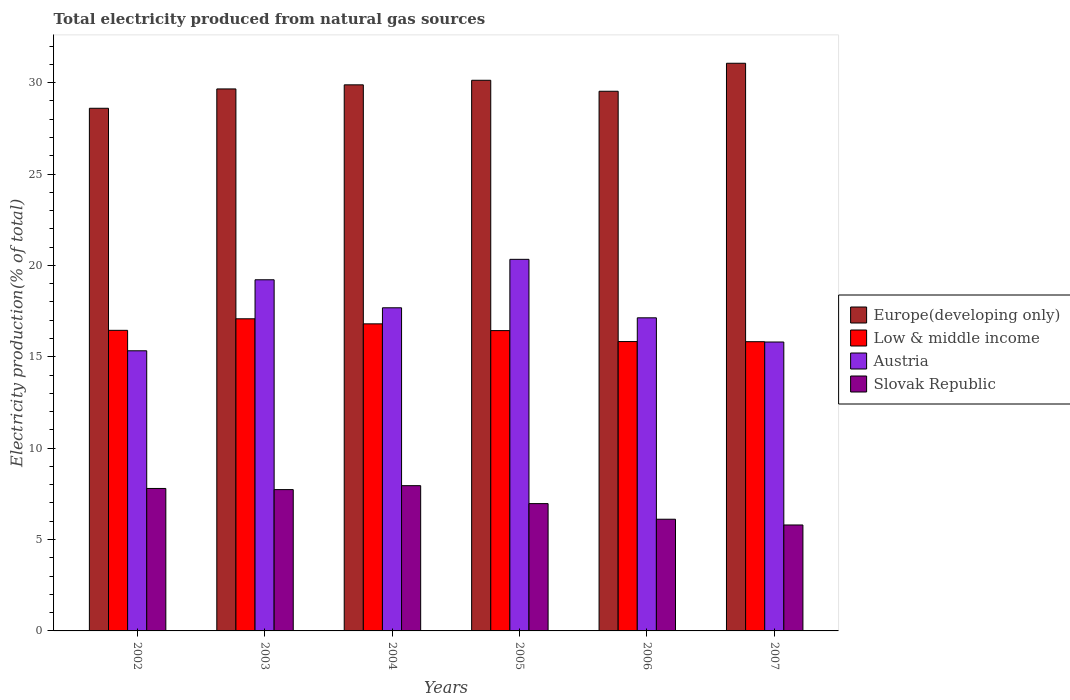How many groups of bars are there?
Keep it short and to the point. 6. Are the number of bars on each tick of the X-axis equal?
Your answer should be very brief. Yes. How many bars are there on the 4th tick from the right?
Make the answer very short. 4. What is the label of the 2nd group of bars from the left?
Make the answer very short. 2003. What is the total electricity produced in Austria in 2004?
Provide a succinct answer. 17.68. Across all years, what is the maximum total electricity produced in Slovak Republic?
Provide a short and direct response. 7.95. Across all years, what is the minimum total electricity produced in Low & middle income?
Offer a terse response. 15.83. In which year was the total electricity produced in Slovak Republic maximum?
Offer a terse response. 2004. What is the total total electricity produced in Low & middle income in the graph?
Provide a short and direct response. 98.42. What is the difference between the total electricity produced in Europe(developing only) in 2003 and that in 2005?
Make the answer very short. -0.47. What is the difference between the total electricity produced in Low & middle income in 2005 and the total electricity produced in Slovak Republic in 2004?
Give a very brief answer. 8.48. What is the average total electricity produced in Europe(developing only) per year?
Make the answer very short. 29.81. In the year 2003, what is the difference between the total electricity produced in Austria and total electricity produced in Europe(developing only)?
Give a very brief answer. -10.44. In how many years, is the total electricity produced in Slovak Republic greater than 1 %?
Your answer should be compact. 6. What is the ratio of the total electricity produced in Austria in 2003 to that in 2007?
Your answer should be compact. 1.22. Is the total electricity produced in Low & middle income in 2002 less than that in 2005?
Your answer should be very brief. No. Is the difference between the total electricity produced in Austria in 2005 and 2006 greater than the difference between the total electricity produced in Europe(developing only) in 2005 and 2006?
Provide a succinct answer. Yes. What is the difference between the highest and the second highest total electricity produced in Europe(developing only)?
Offer a terse response. 0.93. What is the difference between the highest and the lowest total electricity produced in Slovak Republic?
Provide a short and direct response. 2.15. What does the 4th bar from the right in 2007 represents?
Give a very brief answer. Europe(developing only). How many bars are there?
Make the answer very short. 24. Are all the bars in the graph horizontal?
Your response must be concise. No. How many years are there in the graph?
Provide a short and direct response. 6. What is the difference between two consecutive major ticks on the Y-axis?
Ensure brevity in your answer.  5. Are the values on the major ticks of Y-axis written in scientific E-notation?
Your answer should be very brief. No. Does the graph contain any zero values?
Provide a succinct answer. No. Does the graph contain grids?
Provide a short and direct response. No. How many legend labels are there?
Keep it short and to the point. 4. How are the legend labels stacked?
Provide a succinct answer. Vertical. What is the title of the graph?
Your answer should be compact. Total electricity produced from natural gas sources. What is the label or title of the X-axis?
Provide a succinct answer. Years. What is the label or title of the Y-axis?
Ensure brevity in your answer.  Electricity production(% of total). What is the Electricity production(% of total) in Europe(developing only) in 2002?
Provide a short and direct response. 28.6. What is the Electricity production(% of total) of Low & middle income in 2002?
Your answer should be very brief. 16.45. What is the Electricity production(% of total) of Austria in 2002?
Keep it short and to the point. 15.33. What is the Electricity production(% of total) of Slovak Republic in 2002?
Offer a terse response. 7.8. What is the Electricity production(% of total) of Europe(developing only) in 2003?
Keep it short and to the point. 29.66. What is the Electricity production(% of total) in Low & middle income in 2003?
Your answer should be compact. 17.08. What is the Electricity production(% of total) of Austria in 2003?
Offer a terse response. 19.21. What is the Electricity production(% of total) in Slovak Republic in 2003?
Give a very brief answer. 7.73. What is the Electricity production(% of total) in Europe(developing only) in 2004?
Offer a very short reply. 29.88. What is the Electricity production(% of total) in Low & middle income in 2004?
Provide a short and direct response. 16.8. What is the Electricity production(% of total) of Austria in 2004?
Your response must be concise. 17.68. What is the Electricity production(% of total) of Slovak Republic in 2004?
Give a very brief answer. 7.95. What is the Electricity production(% of total) of Europe(developing only) in 2005?
Provide a short and direct response. 30.13. What is the Electricity production(% of total) in Low & middle income in 2005?
Provide a succinct answer. 16.43. What is the Electricity production(% of total) of Austria in 2005?
Offer a very short reply. 20.33. What is the Electricity production(% of total) of Slovak Republic in 2005?
Ensure brevity in your answer.  6.97. What is the Electricity production(% of total) of Europe(developing only) in 2006?
Your answer should be very brief. 29.53. What is the Electricity production(% of total) of Low & middle income in 2006?
Ensure brevity in your answer.  15.83. What is the Electricity production(% of total) of Austria in 2006?
Provide a succinct answer. 17.13. What is the Electricity production(% of total) in Slovak Republic in 2006?
Keep it short and to the point. 6.11. What is the Electricity production(% of total) of Europe(developing only) in 2007?
Give a very brief answer. 31.06. What is the Electricity production(% of total) of Low & middle income in 2007?
Offer a terse response. 15.83. What is the Electricity production(% of total) of Austria in 2007?
Offer a very short reply. 15.81. What is the Electricity production(% of total) of Slovak Republic in 2007?
Your answer should be compact. 5.8. Across all years, what is the maximum Electricity production(% of total) in Europe(developing only)?
Your response must be concise. 31.06. Across all years, what is the maximum Electricity production(% of total) of Low & middle income?
Your answer should be very brief. 17.08. Across all years, what is the maximum Electricity production(% of total) of Austria?
Your answer should be very brief. 20.33. Across all years, what is the maximum Electricity production(% of total) of Slovak Republic?
Provide a short and direct response. 7.95. Across all years, what is the minimum Electricity production(% of total) of Europe(developing only)?
Your answer should be very brief. 28.6. Across all years, what is the minimum Electricity production(% of total) of Low & middle income?
Make the answer very short. 15.83. Across all years, what is the minimum Electricity production(% of total) of Austria?
Offer a terse response. 15.33. Across all years, what is the minimum Electricity production(% of total) in Slovak Republic?
Your answer should be very brief. 5.8. What is the total Electricity production(% of total) in Europe(developing only) in the graph?
Your answer should be very brief. 178.86. What is the total Electricity production(% of total) of Low & middle income in the graph?
Offer a terse response. 98.42. What is the total Electricity production(% of total) in Austria in the graph?
Your answer should be very brief. 105.5. What is the total Electricity production(% of total) in Slovak Republic in the graph?
Your response must be concise. 42.35. What is the difference between the Electricity production(% of total) in Europe(developing only) in 2002 and that in 2003?
Provide a succinct answer. -1.06. What is the difference between the Electricity production(% of total) in Low & middle income in 2002 and that in 2003?
Make the answer very short. -0.63. What is the difference between the Electricity production(% of total) of Austria in 2002 and that in 2003?
Offer a terse response. -3.89. What is the difference between the Electricity production(% of total) of Slovak Republic in 2002 and that in 2003?
Offer a very short reply. 0.06. What is the difference between the Electricity production(% of total) in Europe(developing only) in 2002 and that in 2004?
Provide a short and direct response. -1.28. What is the difference between the Electricity production(% of total) in Low & middle income in 2002 and that in 2004?
Ensure brevity in your answer.  -0.35. What is the difference between the Electricity production(% of total) of Austria in 2002 and that in 2004?
Your answer should be very brief. -2.35. What is the difference between the Electricity production(% of total) in Slovak Republic in 2002 and that in 2004?
Provide a short and direct response. -0.15. What is the difference between the Electricity production(% of total) in Europe(developing only) in 2002 and that in 2005?
Provide a short and direct response. -1.53. What is the difference between the Electricity production(% of total) of Low & middle income in 2002 and that in 2005?
Offer a very short reply. 0.01. What is the difference between the Electricity production(% of total) of Austria in 2002 and that in 2005?
Give a very brief answer. -5. What is the difference between the Electricity production(% of total) in Slovak Republic in 2002 and that in 2005?
Offer a very short reply. 0.83. What is the difference between the Electricity production(% of total) in Europe(developing only) in 2002 and that in 2006?
Keep it short and to the point. -0.93. What is the difference between the Electricity production(% of total) of Low & middle income in 2002 and that in 2006?
Ensure brevity in your answer.  0.61. What is the difference between the Electricity production(% of total) in Austria in 2002 and that in 2006?
Offer a very short reply. -1.8. What is the difference between the Electricity production(% of total) in Slovak Republic in 2002 and that in 2006?
Make the answer very short. 1.68. What is the difference between the Electricity production(% of total) of Europe(developing only) in 2002 and that in 2007?
Ensure brevity in your answer.  -2.46. What is the difference between the Electricity production(% of total) in Low & middle income in 2002 and that in 2007?
Give a very brief answer. 0.62. What is the difference between the Electricity production(% of total) in Austria in 2002 and that in 2007?
Ensure brevity in your answer.  -0.48. What is the difference between the Electricity production(% of total) in Slovak Republic in 2002 and that in 2007?
Offer a terse response. 2. What is the difference between the Electricity production(% of total) of Europe(developing only) in 2003 and that in 2004?
Provide a succinct answer. -0.22. What is the difference between the Electricity production(% of total) of Low & middle income in 2003 and that in 2004?
Your answer should be compact. 0.28. What is the difference between the Electricity production(% of total) of Austria in 2003 and that in 2004?
Make the answer very short. 1.53. What is the difference between the Electricity production(% of total) in Slovak Republic in 2003 and that in 2004?
Keep it short and to the point. -0.22. What is the difference between the Electricity production(% of total) in Europe(developing only) in 2003 and that in 2005?
Your answer should be compact. -0.47. What is the difference between the Electricity production(% of total) in Low & middle income in 2003 and that in 2005?
Your answer should be compact. 0.65. What is the difference between the Electricity production(% of total) of Austria in 2003 and that in 2005?
Make the answer very short. -1.12. What is the difference between the Electricity production(% of total) of Slovak Republic in 2003 and that in 2005?
Your response must be concise. 0.77. What is the difference between the Electricity production(% of total) in Europe(developing only) in 2003 and that in 2006?
Offer a terse response. 0.13. What is the difference between the Electricity production(% of total) of Low & middle income in 2003 and that in 2006?
Ensure brevity in your answer.  1.25. What is the difference between the Electricity production(% of total) in Austria in 2003 and that in 2006?
Your answer should be very brief. 2.08. What is the difference between the Electricity production(% of total) of Slovak Republic in 2003 and that in 2006?
Provide a succinct answer. 1.62. What is the difference between the Electricity production(% of total) of Europe(developing only) in 2003 and that in 2007?
Offer a very short reply. -1.41. What is the difference between the Electricity production(% of total) of Low & middle income in 2003 and that in 2007?
Keep it short and to the point. 1.25. What is the difference between the Electricity production(% of total) in Austria in 2003 and that in 2007?
Keep it short and to the point. 3.41. What is the difference between the Electricity production(% of total) in Slovak Republic in 2003 and that in 2007?
Offer a terse response. 1.94. What is the difference between the Electricity production(% of total) of Low & middle income in 2004 and that in 2005?
Make the answer very short. 0.37. What is the difference between the Electricity production(% of total) in Austria in 2004 and that in 2005?
Your answer should be compact. -2.65. What is the difference between the Electricity production(% of total) in Slovak Republic in 2004 and that in 2005?
Offer a very short reply. 0.98. What is the difference between the Electricity production(% of total) in Europe(developing only) in 2004 and that in 2006?
Provide a succinct answer. 0.35. What is the difference between the Electricity production(% of total) in Low & middle income in 2004 and that in 2006?
Your response must be concise. 0.97. What is the difference between the Electricity production(% of total) of Austria in 2004 and that in 2006?
Your response must be concise. 0.55. What is the difference between the Electricity production(% of total) of Slovak Republic in 2004 and that in 2006?
Offer a terse response. 1.84. What is the difference between the Electricity production(% of total) of Europe(developing only) in 2004 and that in 2007?
Offer a very short reply. -1.18. What is the difference between the Electricity production(% of total) of Low & middle income in 2004 and that in 2007?
Your answer should be compact. 0.98. What is the difference between the Electricity production(% of total) of Austria in 2004 and that in 2007?
Provide a succinct answer. 1.87. What is the difference between the Electricity production(% of total) in Slovak Republic in 2004 and that in 2007?
Your answer should be compact. 2.15. What is the difference between the Electricity production(% of total) in Europe(developing only) in 2005 and that in 2006?
Offer a very short reply. 0.6. What is the difference between the Electricity production(% of total) in Low & middle income in 2005 and that in 2006?
Give a very brief answer. 0.6. What is the difference between the Electricity production(% of total) in Austria in 2005 and that in 2006?
Your answer should be compact. 3.2. What is the difference between the Electricity production(% of total) in Slovak Republic in 2005 and that in 2006?
Offer a very short reply. 0.85. What is the difference between the Electricity production(% of total) in Europe(developing only) in 2005 and that in 2007?
Provide a succinct answer. -0.93. What is the difference between the Electricity production(% of total) in Low & middle income in 2005 and that in 2007?
Your answer should be compact. 0.61. What is the difference between the Electricity production(% of total) of Austria in 2005 and that in 2007?
Offer a very short reply. 4.52. What is the difference between the Electricity production(% of total) in Slovak Republic in 2005 and that in 2007?
Your response must be concise. 1.17. What is the difference between the Electricity production(% of total) in Europe(developing only) in 2006 and that in 2007?
Your answer should be very brief. -1.53. What is the difference between the Electricity production(% of total) of Low & middle income in 2006 and that in 2007?
Provide a succinct answer. 0.01. What is the difference between the Electricity production(% of total) of Austria in 2006 and that in 2007?
Keep it short and to the point. 1.32. What is the difference between the Electricity production(% of total) in Slovak Republic in 2006 and that in 2007?
Provide a short and direct response. 0.31. What is the difference between the Electricity production(% of total) in Europe(developing only) in 2002 and the Electricity production(% of total) in Low & middle income in 2003?
Keep it short and to the point. 11.52. What is the difference between the Electricity production(% of total) of Europe(developing only) in 2002 and the Electricity production(% of total) of Austria in 2003?
Offer a terse response. 9.38. What is the difference between the Electricity production(% of total) of Europe(developing only) in 2002 and the Electricity production(% of total) of Slovak Republic in 2003?
Provide a short and direct response. 20.87. What is the difference between the Electricity production(% of total) in Low & middle income in 2002 and the Electricity production(% of total) in Austria in 2003?
Provide a succinct answer. -2.77. What is the difference between the Electricity production(% of total) in Low & middle income in 2002 and the Electricity production(% of total) in Slovak Republic in 2003?
Make the answer very short. 8.72. What is the difference between the Electricity production(% of total) of Austria in 2002 and the Electricity production(% of total) of Slovak Republic in 2003?
Your answer should be very brief. 7.6. What is the difference between the Electricity production(% of total) of Europe(developing only) in 2002 and the Electricity production(% of total) of Low & middle income in 2004?
Your answer should be very brief. 11.8. What is the difference between the Electricity production(% of total) in Europe(developing only) in 2002 and the Electricity production(% of total) in Austria in 2004?
Provide a short and direct response. 10.92. What is the difference between the Electricity production(% of total) of Europe(developing only) in 2002 and the Electricity production(% of total) of Slovak Republic in 2004?
Provide a succinct answer. 20.65. What is the difference between the Electricity production(% of total) of Low & middle income in 2002 and the Electricity production(% of total) of Austria in 2004?
Your answer should be compact. -1.23. What is the difference between the Electricity production(% of total) of Low & middle income in 2002 and the Electricity production(% of total) of Slovak Republic in 2004?
Provide a succinct answer. 8.5. What is the difference between the Electricity production(% of total) in Austria in 2002 and the Electricity production(% of total) in Slovak Republic in 2004?
Ensure brevity in your answer.  7.38. What is the difference between the Electricity production(% of total) of Europe(developing only) in 2002 and the Electricity production(% of total) of Low & middle income in 2005?
Ensure brevity in your answer.  12.17. What is the difference between the Electricity production(% of total) of Europe(developing only) in 2002 and the Electricity production(% of total) of Austria in 2005?
Offer a terse response. 8.27. What is the difference between the Electricity production(% of total) in Europe(developing only) in 2002 and the Electricity production(% of total) in Slovak Republic in 2005?
Give a very brief answer. 21.63. What is the difference between the Electricity production(% of total) of Low & middle income in 2002 and the Electricity production(% of total) of Austria in 2005?
Provide a succinct answer. -3.88. What is the difference between the Electricity production(% of total) in Low & middle income in 2002 and the Electricity production(% of total) in Slovak Republic in 2005?
Your answer should be very brief. 9.48. What is the difference between the Electricity production(% of total) of Austria in 2002 and the Electricity production(% of total) of Slovak Republic in 2005?
Keep it short and to the point. 8.36. What is the difference between the Electricity production(% of total) of Europe(developing only) in 2002 and the Electricity production(% of total) of Low & middle income in 2006?
Offer a very short reply. 12.77. What is the difference between the Electricity production(% of total) of Europe(developing only) in 2002 and the Electricity production(% of total) of Austria in 2006?
Provide a short and direct response. 11.47. What is the difference between the Electricity production(% of total) in Europe(developing only) in 2002 and the Electricity production(% of total) in Slovak Republic in 2006?
Give a very brief answer. 22.49. What is the difference between the Electricity production(% of total) of Low & middle income in 2002 and the Electricity production(% of total) of Austria in 2006?
Offer a very short reply. -0.68. What is the difference between the Electricity production(% of total) of Low & middle income in 2002 and the Electricity production(% of total) of Slovak Republic in 2006?
Your answer should be very brief. 10.34. What is the difference between the Electricity production(% of total) in Austria in 2002 and the Electricity production(% of total) in Slovak Republic in 2006?
Offer a terse response. 9.22. What is the difference between the Electricity production(% of total) in Europe(developing only) in 2002 and the Electricity production(% of total) in Low & middle income in 2007?
Your answer should be compact. 12.77. What is the difference between the Electricity production(% of total) of Europe(developing only) in 2002 and the Electricity production(% of total) of Austria in 2007?
Your answer should be compact. 12.79. What is the difference between the Electricity production(% of total) in Europe(developing only) in 2002 and the Electricity production(% of total) in Slovak Republic in 2007?
Ensure brevity in your answer.  22.8. What is the difference between the Electricity production(% of total) in Low & middle income in 2002 and the Electricity production(% of total) in Austria in 2007?
Provide a succinct answer. 0.64. What is the difference between the Electricity production(% of total) in Low & middle income in 2002 and the Electricity production(% of total) in Slovak Republic in 2007?
Make the answer very short. 10.65. What is the difference between the Electricity production(% of total) of Austria in 2002 and the Electricity production(% of total) of Slovak Republic in 2007?
Give a very brief answer. 9.53. What is the difference between the Electricity production(% of total) in Europe(developing only) in 2003 and the Electricity production(% of total) in Low & middle income in 2004?
Give a very brief answer. 12.85. What is the difference between the Electricity production(% of total) in Europe(developing only) in 2003 and the Electricity production(% of total) in Austria in 2004?
Offer a very short reply. 11.97. What is the difference between the Electricity production(% of total) of Europe(developing only) in 2003 and the Electricity production(% of total) of Slovak Republic in 2004?
Offer a very short reply. 21.71. What is the difference between the Electricity production(% of total) of Low & middle income in 2003 and the Electricity production(% of total) of Austria in 2004?
Ensure brevity in your answer.  -0.6. What is the difference between the Electricity production(% of total) of Low & middle income in 2003 and the Electricity production(% of total) of Slovak Republic in 2004?
Offer a terse response. 9.13. What is the difference between the Electricity production(% of total) in Austria in 2003 and the Electricity production(% of total) in Slovak Republic in 2004?
Your answer should be very brief. 11.27. What is the difference between the Electricity production(% of total) of Europe(developing only) in 2003 and the Electricity production(% of total) of Low & middle income in 2005?
Provide a succinct answer. 13.22. What is the difference between the Electricity production(% of total) of Europe(developing only) in 2003 and the Electricity production(% of total) of Austria in 2005?
Offer a terse response. 9.32. What is the difference between the Electricity production(% of total) of Europe(developing only) in 2003 and the Electricity production(% of total) of Slovak Republic in 2005?
Give a very brief answer. 22.69. What is the difference between the Electricity production(% of total) in Low & middle income in 2003 and the Electricity production(% of total) in Austria in 2005?
Your response must be concise. -3.25. What is the difference between the Electricity production(% of total) of Low & middle income in 2003 and the Electricity production(% of total) of Slovak Republic in 2005?
Make the answer very short. 10.11. What is the difference between the Electricity production(% of total) in Austria in 2003 and the Electricity production(% of total) in Slovak Republic in 2005?
Make the answer very short. 12.25. What is the difference between the Electricity production(% of total) in Europe(developing only) in 2003 and the Electricity production(% of total) in Low & middle income in 2006?
Your answer should be compact. 13.82. What is the difference between the Electricity production(% of total) in Europe(developing only) in 2003 and the Electricity production(% of total) in Austria in 2006?
Make the answer very short. 12.52. What is the difference between the Electricity production(% of total) of Europe(developing only) in 2003 and the Electricity production(% of total) of Slovak Republic in 2006?
Provide a succinct answer. 23.54. What is the difference between the Electricity production(% of total) in Low & middle income in 2003 and the Electricity production(% of total) in Austria in 2006?
Keep it short and to the point. -0.05. What is the difference between the Electricity production(% of total) in Low & middle income in 2003 and the Electricity production(% of total) in Slovak Republic in 2006?
Give a very brief answer. 10.97. What is the difference between the Electricity production(% of total) in Austria in 2003 and the Electricity production(% of total) in Slovak Republic in 2006?
Keep it short and to the point. 13.1. What is the difference between the Electricity production(% of total) in Europe(developing only) in 2003 and the Electricity production(% of total) in Low & middle income in 2007?
Your answer should be compact. 13.83. What is the difference between the Electricity production(% of total) in Europe(developing only) in 2003 and the Electricity production(% of total) in Austria in 2007?
Your answer should be compact. 13.85. What is the difference between the Electricity production(% of total) in Europe(developing only) in 2003 and the Electricity production(% of total) in Slovak Republic in 2007?
Your response must be concise. 23.86. What is the difference between the Electricity production(% of total) of Low & middle income in 2003 and the Electricity production(% of total) of Austria in 2007?
Give a very brief answer. 1.27. What is the difference between the Electricity production(% of total) in Low & middle income in 2003 and the Electricity production(% of total) in Slovak Republic in 2007?
Make the answer very short. 11.28. What is the difference between the Electricity production(% of total) in Austria in 2003 and the Electricity production(% of total) in Slovak Republic in 2007?
Keep it short and to the point. 13.42. What is the difference between the Electricity production(% of total) of Europe(developing only) in 2004 and the Electricity production(% of total) of Low & middle income in 2005?
Ensure brevity in your answer.  13.45. What is the difference between the Electricity production(% of total) in Europe(developing only) in 2004 and the Electricity production(% of total) in Austria in 2005?
Your response must be concise. 9.55. What is the difference between the Electricity production(% of total) of Europe(developing only) in 2004 and the Electricity production(% of total) of Slovak Republic in 2005?
Make the answer very short. 22.91. What is the difference between the Electricity production(% of total) of Low & middle income in 2004 and the Electricity production(% of total) of Austria in 2005?
Ensure brevity in your answer.  -3.53. What is the difference between the Electricity production(% of total) in Low & middle income in 2004 and the Electricity production(% of total) in Slovak Republic in 2005?
Ensure brevity in your answer.  9.84. What is the difference between the Electricity production(% of total) of Austria in 2004 and the Electricity production(% of total) of Slovak Republic in 2005?
Provide a short and direct response. 10.72. What is the difference between the Electricity production(% of total) in Europe(developing only) in 2004 and the Electricity production(% of total) in Low & middle income in 2006?
Your answer should be very brief. 14.05. What is the difference between the Electricity production(% of total) of Europe(developing only) in 2004 and the Electricity production(% of total) of Austria in 2006?
Provide a short and direct response. 12.75. What is the difference between the Electricity production(% of total) of Europe(developing only) in 2004 and the Electricity production(% of total) of Slovak Republic in 2006?
Provide a succinct answer. 23.77. What is the difference between the Electricity production(% of total) of Low & middle income in 2004 and the Electricity production(% of total) of Austria in 2006?
Provide a succinct answer. -0.33. What is the difference between the Electricity production(% of total) of Low & middle income in 2004 and the Electricity production(% of total) of Slovak Republic in 2006?
Your response must be concise. 10.69. What is the difference between the Electricity production(% of total) in Austria in 2004 and the Electricity production(% of total) in Slovak Republic in 2006?
Your response must be concise. 11.57. What is the difference between the Electricity production(% of total) in Europe(developing only) in 2004 and the Electricity production(% of total) in Low & middle income in 2007?
Give a very brief answer. 14.05. What is the difference between the Electricity production(% of total) in Europe(developing only) in 2004 and the Electricity production(% of total) in Austria in 2007?
Your response must be concise. 14.07. What is the difference between the Electricity production(% of total) of Europe(developing only) in 2004 and the Electricity production(% of total) of Slovak Republic in 2007?
Make the answer very short. 24.08. What is the difference between the Electricity production(% of total) of Low & middle income in 2004 and the Electricity production(% of total) of Austria in 2007?
Ensure brevity in your answer.  0.99. What is the difference between the Electricity production(% of total) in Low & middle income in 2004 and the Electricity production(% of total) in Slovak Republic in 2007?
Make the answer very short. 11.01. What is the difference between the Electricity production(% of total) of Austria in 2004 and the Electricity production(% of total) of Slovak Republic in 2007?
Keep it short and to the point. 11.88. What is the difference between the Electricity production(% of total) in Europe(developing only) in 2005 and the Electricity production(% of total) in Low & middle income in 2006?
Provide a succinct answer. 14.3. What is the difference between the Electricity production(% of total) in Europe(developing only) in 2005 and the Electricity production(% of total) in Austria in 2006?
Offer a terse response. 13. What is the difference between the Electricity production(% of total) of Europe(developing only) in 2005 and the Electricity production(% of total) of Slovak Republic in 2006?
Provide a succinct answer. 24.02. What is the difference between the Electricity production(% of total) in Low & middle income in 2005 and the Electricity production(% of total) in Austria in 2006?
Keep it short and to the point. -0.7. What is the difference between the Electricity production(% of total) of Low & middle income in 2005 and the Electricity production(% of total) of Slovak Republic in 2006?
Make the answer very short. 10.32. What is the difference between the Electricity production(% of total) in Austria in 2005 and the Electricity production(% of total) in Slovak Republic in 2006?
Make the answer very short. 14.22. What is the difference between the Electricity production(% of total) in Europe(developing only) in 2005 and the Electricity production(% of total) in Low & middle income in 2007?
Ensure brevity in your answer.  14.3. What is the difference between the Electricity production(% of total) in Europe(developing only) in 2005 and the Electricity production(% of total) in Austria in 2007?
Your answer should be compact. 14.32. What is the difference between the Electricity production(% of total) of Europe(developing only) in 2005 and the Electricity production(% of total) of Slovak Republic in 2007?
Provide a succinct answer. 24.33. What is the difference between the Electricity production(% of total) of Low & middle income in 2005 and the Electricity production(% of total) of Austria in 2007?
Offer a terse response. 0.62. What is the difference between the Electricity production(% of total) in Low & middle income in 2005 and the Electricity production(% of total) in Slovak Republic in 2007?
Your response must be concise. 10.64. What is the difference between the Electricity production(% of total) in Austria in 2005 and the Electricity production(% of total) in Slovak Republic in 2007?
Your answer should be very brief. 14.53. What is the difference between the Electricity production(% of total) of Europe(developing only) in 2006 and the Electricity production(% of total) of Low & middle income in 2007?
Make the answer very short. 13.7. What is the difference between the Electricity production(% of total) of Europe(developing only) in 2006 and the Electricity production(% of total) of Austria in 2007?
Offer a very short reply. 13.72. What is the difference between the Electricity production(% of total) in Europe(developing only) in 2006 and the Electricity production(% of total) in Slovak Republic in 2007?
Your answer should be very brief. 23.73. What is the difference between the Electricity production(% of total) of Low & middle income in 2006 and the Electricity production(% of total) of Austria in 2007?
Provide a short and direct response. 0.02. What is the difference between the Electricity production(% of total) in Low & middle income in 2006 and the Electricity production(% of total) in Slovak Republic in 2007?
Your response must be concise. 10.04. What is the difference between the Electricity production(% of total) of Austria in 2006 and the Electricity production(% of total) of Slovak Republic in 2007?
Your answer should be compact. 11.34. What is the average Electricity production(% of total) in Europe(developing only) per year?
Make the answer very short. 29.81. What is the average Electricity production(% of total) of Low & middle income per year?
Offer a terse response. 16.4. What is the average Electricity production(% of total) in Austria per year?
Your answer should be very brief. 17.58. What is the average Electricity production(% of total) of Slovak Republic per year?
Your answer should be compact. 7.06. In the year 2002, what is the difference between the Electricity production(% of total) of Europe(developing only) and Electricity production(% of total) of Low & middle income?
Give a very brief answer. 12.15. In the year 2002, what is the difference between the Electricity production(% of total) in Europe(developing only) and Electricity production(% of total) in Austria?
Provide a short and direct response. 13.27. In the year 2002, what is the difference between the Electricity production(% of total) of Europe(developing only) and Electricity production(% of total) of Slovak Republic?
Your response must be concise. 20.8. In the year 2002, what is the difference between the Electricity production(% of total) of Low & middle income and Electricity production(% of total) of Austria?
Make the answer very short. 1.12. In the year 2002, what is the difference between the Electricity production(% of total) in Low & middle income and Electricity production(% of total) in Slovak Republic?
Provide a short and direct response. 8.65. In the year 2002, what is the difference between the Electricity production(% of total) of Austria and Electricity production(% of total) of Slovak Republic?
Provide a succinct answer. 7.53. In the year 2003, what is the difference between the Electricity production(% of total) in Europe(developing only) and Electricity production(% of total) in Low & middle income?
Make the answer very short. 12.58. In the year 2003, what is the difference between the Electricity production(% of total) of Europe(developing only) and Electricity production(% of total) of Austria?
Offer a very short reply. 10.44. In the year 2003, what is the difference between the Electricity production(% of total) of Europe(developing only) and Electricity production(% of total) of Slovak Republic?
Make the answer very short. 21.92. In the year 2003, what is the difference between the Electricity production(% of total) in Low & middle income and Electricity production(% of total) in Austria?
Make the answer very short. -2.14. In the year 2003, what is the difference between the Electricity production(% of total) in Low & middle income and Electricity production(% of total) in Slovak Republic?
Provide a succinct answer. 9.35. In the year 2003, what is the difference between the Electricity production(% of total) of Austria and Electricity production(% of total) of Slovak Republic?
Make the answer very short. 11.48. In the year 2004, what is the difference between the Electricity production(% of total) in Europe(developing only) and Electricity production(% of total) in Low & middle income?
Your answer should be compact. 13.08. In the year 2004, what is the difference between the Electricity production(% of total) of Europe(developing only) and Electricity production(% of total) of Austria?
Keep it short and to the point. 12.2. In the year 2004, what is the difference between the Electricity production(% of total) in Europe(developing only) and Electricity production(% of total) in Slovak Republic?
Your answer should be compact. 21.93. In the year 2004, what is the difference between the Electricity production(% of total) in Low & middle income and Electricity production(% of total) in Austria?
Make the answer very short. -0.88. In the year 2004, what is the difference between the Electricity production(% of total) of Low & middle income and Electricity production(% of total) of Slovak Republic?
Keep it short and to the point. 8.85. In the year 2004, what is the difference between the Electricity production(% of total) of Austria and Electricity production(% of total) of Slovak Republic?
Provide a succinct answer. 9.73. In the year 2005, what is the difference between the Electricity production(% of total) in Europe(developing only) and Electricity production(% of total) in Low & middle income?
Offer a very short reply. 13.7. In the year 2005, what is the difference between the Electricity production(% of total) in Europe(developing only) and Electricity production(% of total) in Austria?
Keep it short and to the point. 9.8. In the year 2005, what is the difference between the Electricity production(% of total) in Europe(developing only) and Electricity production(% of total) in Slovak Republic?
Give a very brief answer. 23.16. In the year 2005, what is the difference between the Electricity production(% of total) of Low & middle income and Electricity production(% of total) of Austria?
Your answer should be very brief. -3.9. In the year 2005, what is the difference between the Electricity production(% of total) in Low & middle income and Electricity production(% of total) in Slovak Republic?
Provide a succinct answer. 9.47. In the year 2005, what is the difference between the Electricity production(% of total) in Austria and Electricity production(% of total) in Slovak Republic?
Offer a terse response. 13.37. In the year 2006, what is the difference between the Electricity production(% of total) in Europe(developing only) and Electricity production(% of total) in Low & middle income?
Keep it short and to the point. 13.7. In the year 2006, what is the difference between the Electricity production(% of total) of Europe(developing only) and Electricity production(% of total) of Austria?
Offer a terse response. 12.4. In the year 2006, what is the difference between the Electricity production(% of total) in Europe(developing only) and Electricity production(% of total) in Slovak Republic?
Keep it short and to the point. 23.42. In the year 2006, what is the difference between the Electricity production(% of total) in Low & middle income and Electricity production(% of total) in Austria?
Offer a very short reply. -1.3. In the year 2006, what is the difference between the Electricity production(% of total) of Low & middle income and Electricity production(% of total) of Slovak Republic?
Provide a short and direct response. 9.72. In the year 2006, what is the difference between the Electricity production(% of total) of Austria and Electricity production(% of total) of Slovak Republic?
Make the answer very short. 11.02. In the year 2007, what is the difference between the Electricity production(% of total) of Europe(developing only) and Electricity production(% of total) of Low & middle income?
Give a very brief answer. 15.24. In the year 2007, what is the difference between the Electricity production(% of total) of Europe(developing only) and Electricity production(% of total) of Austria?
Provide a succinct answer. 15.25. In the year 2007, what is the difference between the Electricity production(% of total) of Europe(developing only) and Electricity production(% of total) of Slovak Republic?
Keep it short and to the point. 25.26. In the year 2007, what is the difference between the Electricity production(% of total) of Low & middle income and Electricity production(% of total) of Austria?
Ensure brevity in your answer.  0.02. In the year 2007, what is the difference between the Electricity production(% of total) in Low & middle income and Electricity production(% of total) in Slovak Republic?
Your answer should be compact. 10.03. In the year 2007, what is the difference between the Electricity production(% of total) of Austria and Electricity production(% of total) of Slovak Republic?
Provide a short and direct response. 10.01. What is the ratio of the Electricity production(% of total) in Austria in 2002 to that in 2003?
Your answer should be very brief. 0.8. What is the ratio of the Electricity production(% of total) in Europe(developing only) in 2002 to that in 2004?
Offer a very short reply. 0.96. What is the ratio of the Electricity production(% of total) in Low & middle income in 2002 to that in 2004?
Give a very brief answer. 0.98. What is the ratio of the Electricity production(% of total) in Austria in 2002 to that in 2004?
Offer a very short reply. 0.87. What is the ratio of the Electricity production(% of total) of Slovak Republic in 2002 to that in 2004?
Keep it short and to the point. 0.98. What is the ratio of the Electricity production(% of total) of Europe(developing only) in 2002 to that in 2005?
Keep it short and to the point. 0.95. What is the ratio of the Electricity production(% of total) of Austria in 2002 to that in 2005?
Give a very brief answer. 0.75. What is the ratio of the Electricity production(% of total) in Slovak Republic in 2002 to that in 2005?
Provide a short and direct response. 1.12. What is the ratio of the Electricity production(% of total) in Europe(developing only) in 2002 to that in 2006?
Your answer should be compact. 0.97. What is the ratio of the Electricity production(% of total) of Low & middle income in 2002 to that in 2006?
Provide a short and direct response. 1.04. What is the ratio of the Electricity production(% of total) of Austria in 2002 to that in 2006?
Make the answer very short. 0.89. What is the ratio of the Electricity production(% of total) in Slovak Republic in 2002 to that in 2006?
Your answer should be compact. 1.28. What is the ratio of the Electricity production(% of total) of Europe(developing only) in 2002 to that in 2007?
Offer a terse response. 0.92. What is the ratio of the Electricity production(% of total) in Low & middle income in 2002 to that in 2007?
Provide a succinct answer. 1.04. What is the ratio of the Electricity production(% of total) of Austria in 2002 to that in 2007?
Your response must be concise. 0.97. What is the ratio of the Electricity production(% of total) of Slovak Republic in 2002 to that in 2007?
Your answer should be compact. 1.34. What is the ratio of the Electricity production(% of total) in Europe(developing only) in 2003 to that in 2004?
Provide a succinct answer. 0.99. What is the ratio of the Electricity production(% of total) of Low & middle income in 2003 to that in 2004?
Give a very brief answer. 1.02. What is the ratio of the Electricity production(% of total) in Austria in 2003 to that in 2004?
Provide a short and direct response. 1.09. What is the ratio of the Electricity production(% of total) of Slovak Republic in 2003 to that in 2004?
Offer a very short reply. 0.97. What is the ratio of the Electricity production(% of total) in Europe(developing only) in 2003 to that in 2005?
Offer a very short reply. 0.98. What is the ratio of the Electricity production(% of total) of Low & middle income in 2003 to that in 2005?
Make the answer very short. 1.04. What is the ratio of the Electricity production(% of total) of Austria in 2003 to that in 2005?
Ensure brevity in your answer.  0.94. What is the ratio of the Electricity production(% of total) of Slovak Republic in 2003 to that in 2005?
Make the answer very short. 1.11. What is the ratio of the Electricity production(% of total) in Europe(developing only) in 2003 to that in 2006?
Provide a succinct answer. 1. What is the ratio of the Electricity production(% of total) of Low & middle income in 2003 to that in 2006?
Make the answer very short. 1.08. What is the ratio of the Electricity production(% of total) in Austria in 2003 to that in 2006?
Provide a succinct answer. 1.12. What is the ratio of the Electricity production(% of total) of Slovak Republic in 2003 to that in 2006?
Provide a short and direct response. 1.27. What is the ratio of the Electricity production(% of total) in Europe(developing only) in 2003 to that in 2007?
Your answer should be compact. 0.95. What is the ratio of the Electricity production(% of total) of Low & middle income in 2003 to that in 2007?
Your answer should be very brief. 1.08. What is the ratio of the Electricity production(% of total) of Austria in 2003 to that in 2007?
Keep it short and to the point. 1.22. What is the ratio of the Electricity production(% of total) of Slovak Republic in 2003 to that in 2007?
Provide a short and direct response. 1.33. What is the ratio of the Electricity production(% of total) in Low & middle income in 2004 to that in 2005?
Your answer should be very brief. 1.02. What is the ratio of the Electricity production(% of total) of Austria in 2004 to that in 2005?
Provide a short and direct response. 0.87. What is the ratio of the Electricity production(% of total) of Slovak Republic in 2004 to that in 2005?
Offer a terse response. 1.14. What is the ratio of the Electricity production(% of total) in Europe(developing only) in 2004 to that in 2006?
Your answer should be compact. 1.01. What is the ratio of the Electricity production(% of total) in Low & middle income in 2004 to that in 2006?
Your answer should be compact. 1.06. What is the ratio of the Electricity production(% of total) of Austria in 2004 to that in 2006?
Ensure brevity in your answer.  1.03. What is the ratio of the Electricity production(% of total) of Slovak Republic in 2004 to that in 2006?
Give a very brief answer. 1.3. What is the ratio of the Electricity production(% of total) in Low & middle income in 2004 to that in 2007?
Make the answer very short. 1.06. What is the ratio of the Electricity production(% of total) in Austria in 2004 to that in 2007?
Your response must be concise. 1.12. What is the ratio of the Electricity production(% of total) in Slovak Republic in 2004 to that in 2007?
Ensure brevity in your answer.  1.37. What is the ratio of the Electricity production(% of total) of Europe(developing only) in 2005 to that in 2006?
Your answer should be very brief. 1.02. What is the ratio of the Electricity production(% of total) in Low & middle income in 2005 to that in 2006?
Your answer should be compact. 1.04. What is the ratio of the Electricity production(% of total) of Austria in 2005 to that in 2006?
Offer a very short reply. 1.19. What is the ratio of the Electricity production(% of total) in Slovak Republic in 2005 to that in 2006?
Keep it short and to the point. 1.14. What is the ratio of the Electricity production(% of total) of Low & middle income in 2005 to that in 2007?
Offer a terse response. 1.04. What is the ratio of the Electricity production(% of total) of Austria in 2005 to that in 2007?
Provide a succinct answer. 1.29. What is the ratio of the Electricity production(% of total) of Slovak Republic in 2005 to that in 2007?
Provide a short and direct response. 1.2. What is the ratio of the Electricity production(% of total) of Europe(developing only) in 2006 to that in 2007?
Provide a succinct answer. 0.95. What is the ratio of the Electricity production(% of total) of Austria in 2006 to that in 2007?
Provide a short and direct response. 1.08. What is the ratio of the Electricity production(% of total) in Slovak Republic in 2006 to that in 2007?
Provide a short and direct response. 1.05. What is the difference between the highest and the second highest Electricity production(% of total) of Europe(developing only)?
Make the answer very short. 0.93. What is the difference between the highest and the second highest Electricity production(% of total) of Low & middle income?
Your response must be concise. 0.28. What is the difference between the highest and the second highest Electricity production(% of total) in Austria?
Your answer should be compact. 1.12. What is the difference between the highest and the second highest Electricity production(% of total) of Slovak Republic?
Provide a succinct answer. 0.15. What is the difference between the highest and the lowest Electricity production(% of total) of Europe(developing only)?
Your answer should be very brief. 2.46. What is the difference between the highest and the lowest Electricity production(% of total) of Low & middle income?
Offer a terse response. 1.25. What is the difference between the highest and the lowest Electricity production(% of total) in Austria?
Give a very brief answer. 5. What is the difference between the highest and the lowest Electricity production(% of total) of Slovak Republic?
Make the answer very short. 2.15. 